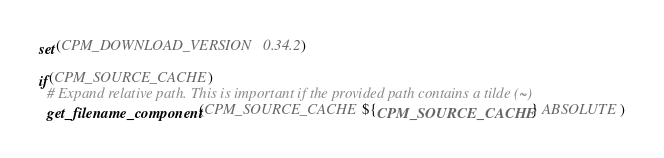<code> <loc_0><loc_0><loc_500><loc_500><_CMake_>set(CPM_DOWNLOAD_VERSION 0.34.2)

if(CPM_SOURCE_CACHE)
  # Expand relative path. This is important if the provided path contains a tilde (~)
  get_filename_component(CPM_SOURCE_CACHE ${CPM_SOURCE_CACHE} ABSOLUTE)</code> 